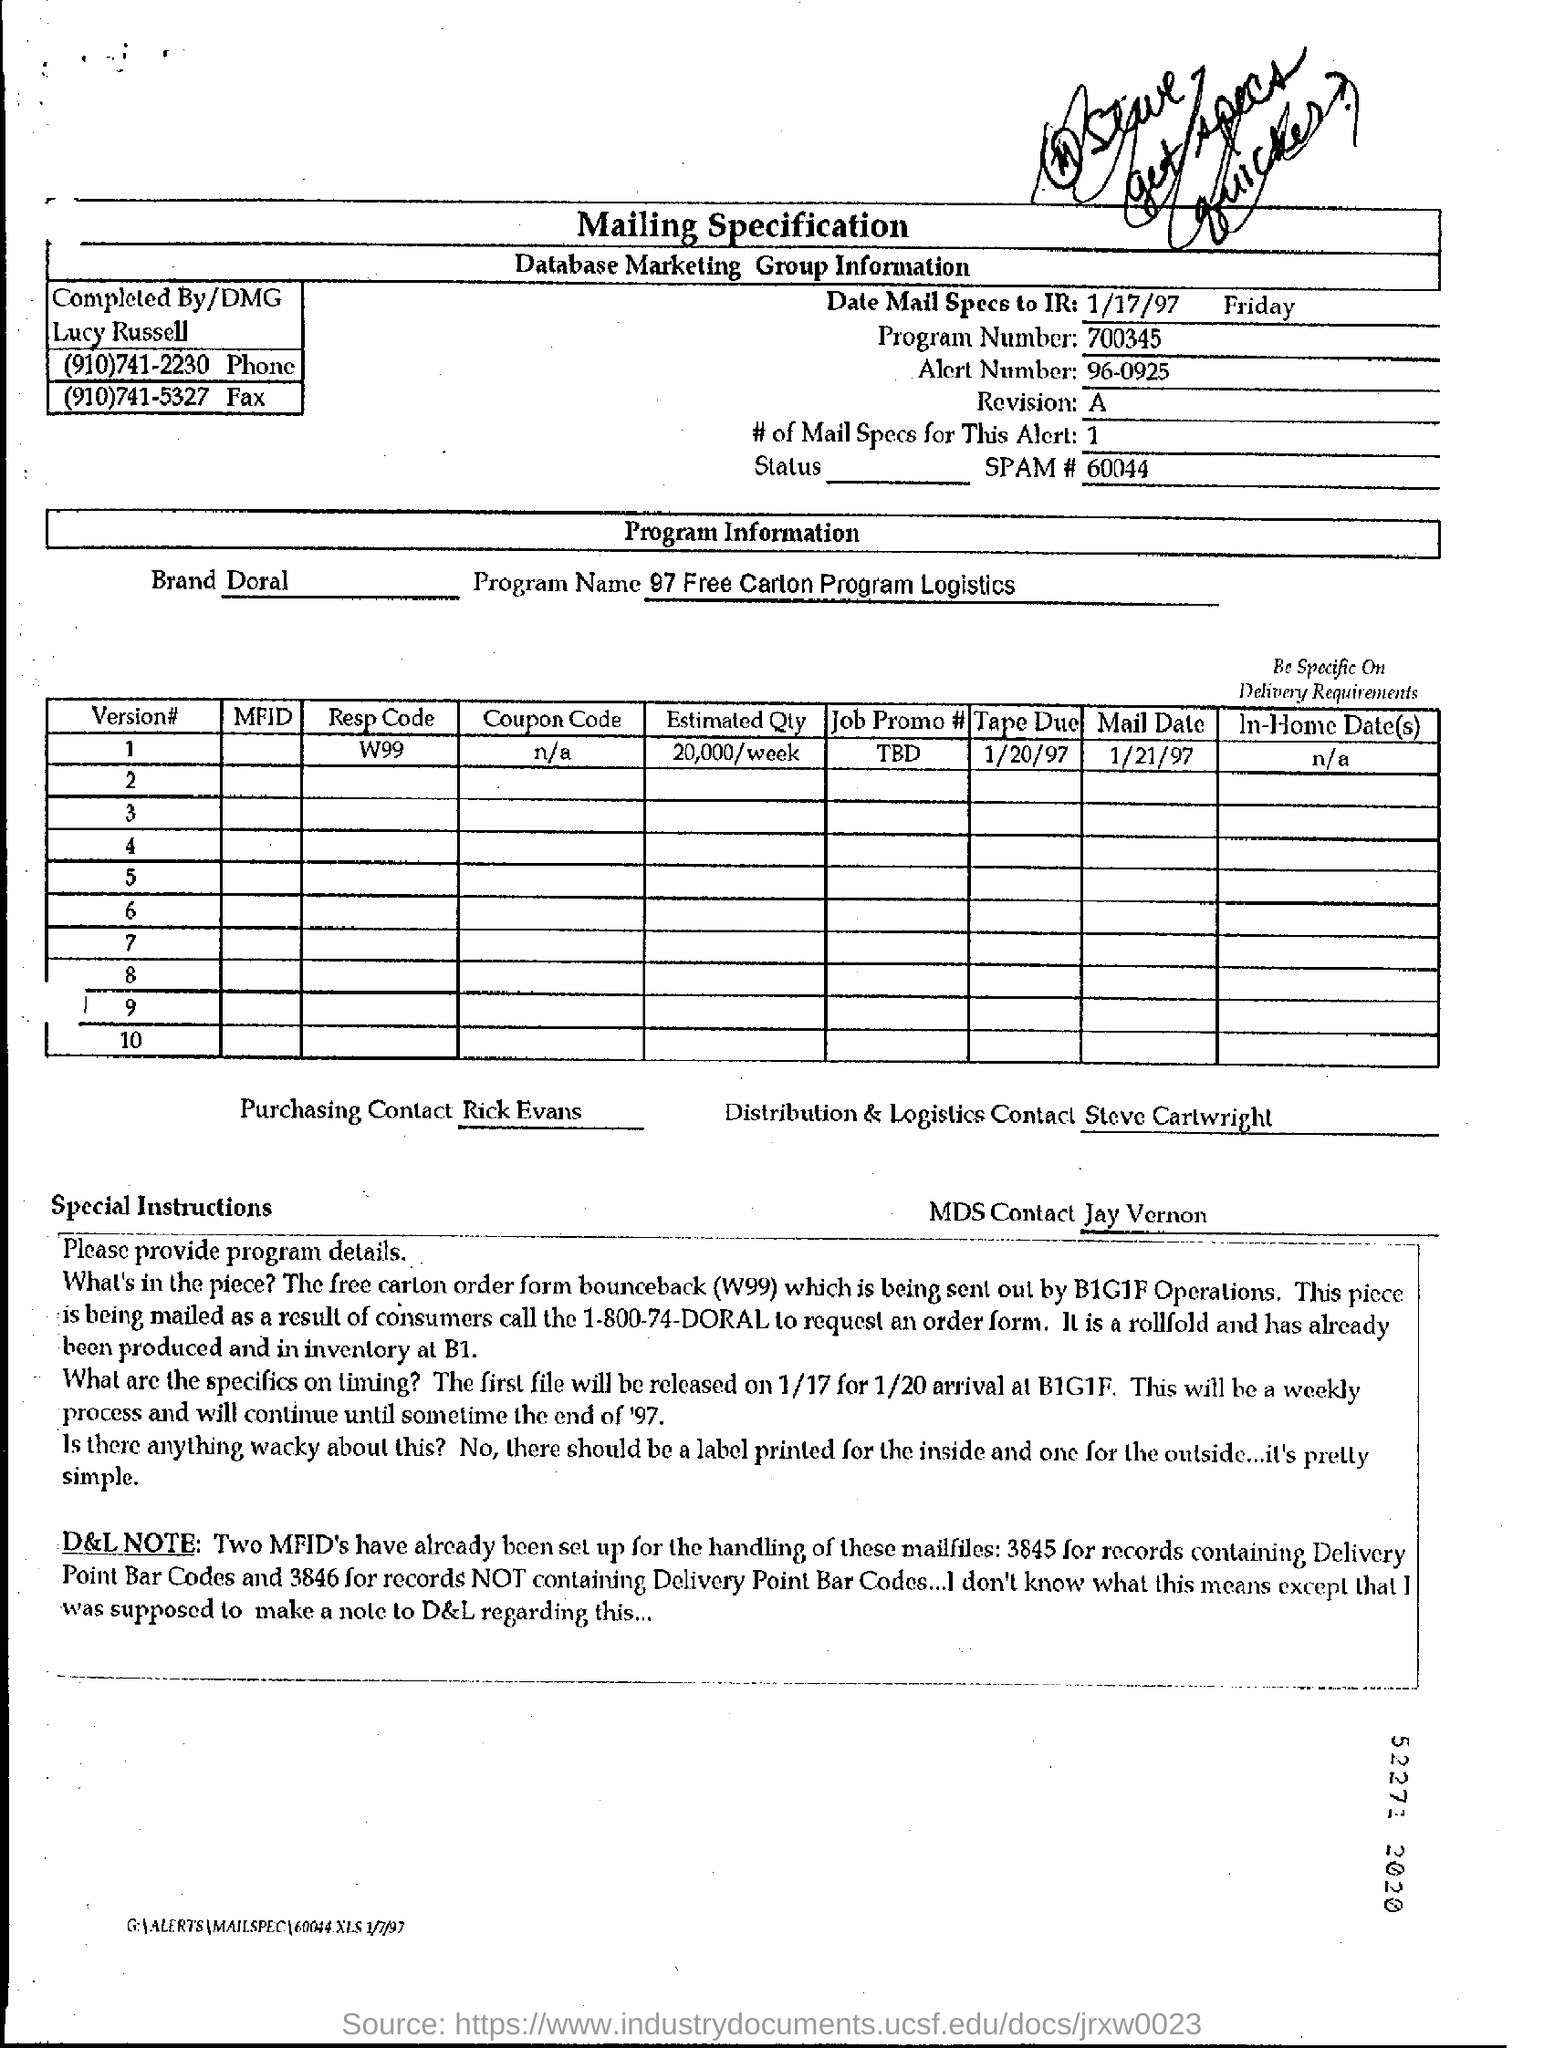Identify some key points in this picture. The program name is 97 Free Carton Program Logistics. The program number is 700345... The response code for version 1 is W99. The brand name is Doral. 